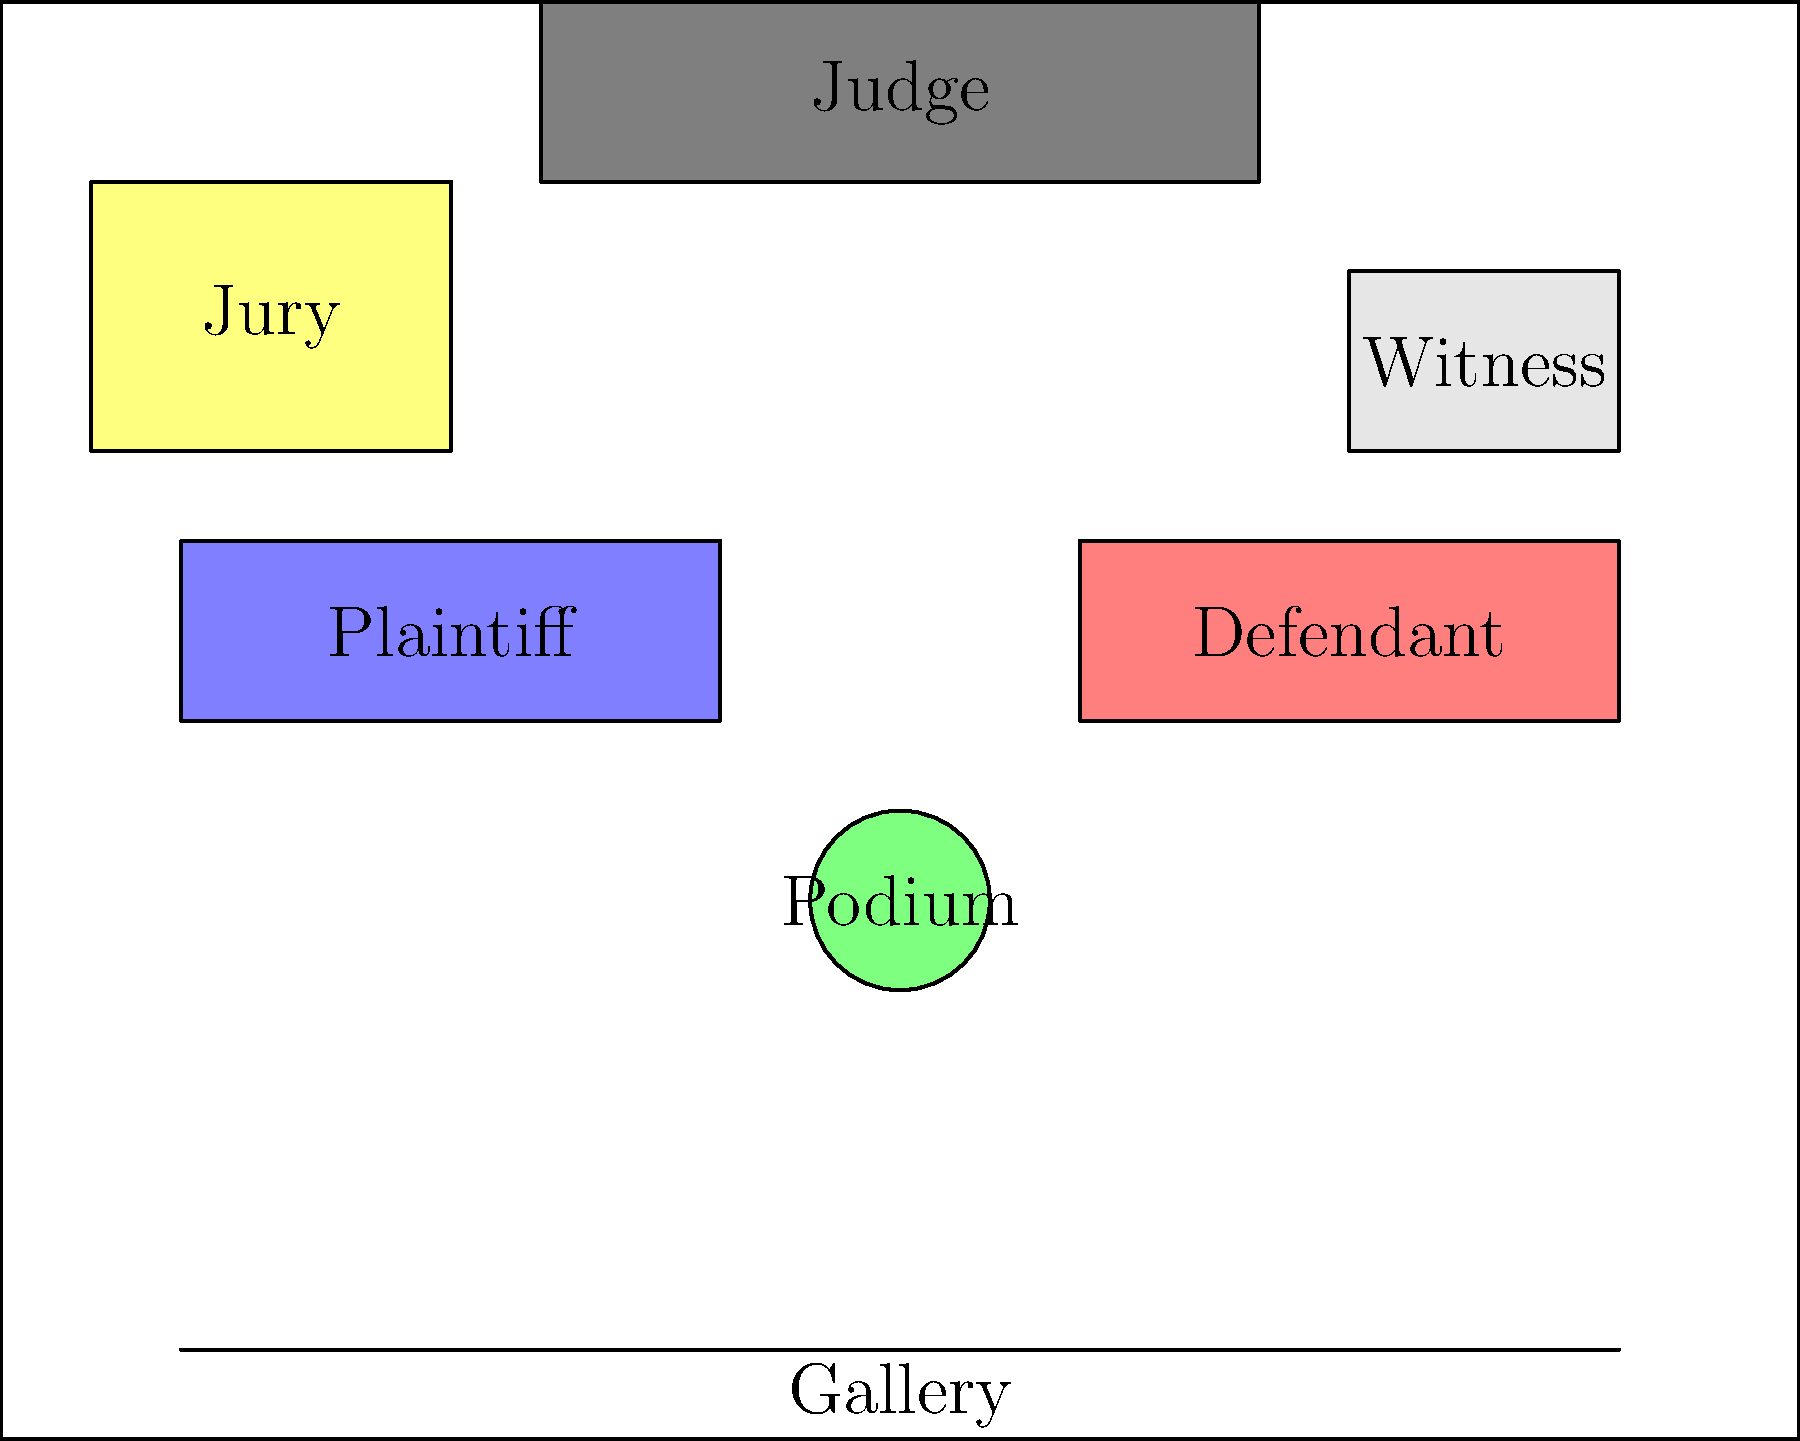In a typical moot court courtroom layout, where is the podium usually positioned in relation to the plaintiff's and defendant's tables? To determine the position of the podium in relation to the plaintiff's and defendant's tables, let's analyze the courtroom layout step-by-step:

1. The courtroom is divided into several key areas, including the judge's bench, witness stand, plaintiff's table, defendant's table, jury box, podium, and gallery.

2. The judge's bench is typically located at the front and center of the courtroom.

3. The plaintiff's table is usually on the left side of the courtroom (from the judge's perspective), while the defendant's table is on the right side.

4. The podium, where attorneys deliver their arguments, is typically positioned in the center of the courtroom, in front of the judge's bench.

5. Looking at the layout, we can see that the podium is placed centrally between the plaintiff's and defendant's tables.

6. The podium is slightly closer to the judge's bench than the tables, allowing attorneys to address both the judge and the jury effectively.

7. This central position enables attorneys from both sides to have equal access to the podium when presenting their arguments.

Based on this analysis, we can conclude that the podium is positioned centrally between and slightly in front of the plaintiff's and defendant's tables.
Answer: Centrally between and slightly in front of both tables 